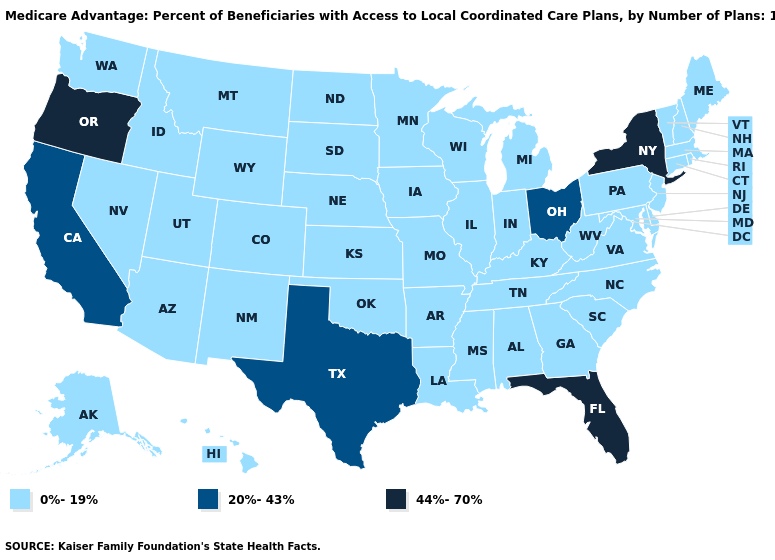Name the states that have a value in the range 0%-19%?
Quick response, please. Alaska, Alabama, Arkansas, Arizona, Colorado, Connecticut, Delaware, Georgia, Hawaii, Iowa, Idaho, Illinois, Indiana, Kansas, Kentucky, Louisiana, Massachusetts, Maryland, Maine, Michigan, Minnesota, Missouri, Mississippi, Montana, North Carolina, North Dakota, Nebraska, New Hampshire, New Jersey, New Mexico, Nevada, Oklahoma, Pennsylvania, Rhode Island, South Carolina, South Dakota, Tennessee, Utah, Virginia, Vermont, Washington, Wisconsin, West Virginia, Wyoming. Does Texas have the lowest value in the South?
Be succinct. No. What is the value of Utah?
Write a very short answer. 0%-19%. Name the states that have a value in the range 44%-70%?
Concise answer only. Florida, New York, Oregon. Which states have the lowest value in the USA?
Keep it brief. Alaska, Alabama, Arkansas, Arizona, Colorado, Connecticut, Delaware, Georgia, Hawaii, Iowa, Idaho, Illinois, Indiana, Kansas, Kentucky, Louisiana, Massachusetts, Maryland, Maine, Michigan, Minnesota, Missouri, Mississippi, Montana, North Carolina, North Dakota, Nebraska, New Hampshire, New Jersey, New Mexico, Nevada, Oklahoma, Pennsylvania, Rhode Island, South Carolina, South Dakota, Tennessee, Utah, Virginia, Vermont, Washington, Wisconsin, West Virginia, Wyoming. What is the highest value in the USA?
Concise answer only. 44%-70%. Name the states that have a value in the range 0%-19%?
Keep it brief. Alaska, Alabama, Arkansas, Arizona, Colorado, Connecticut, Delaware, Georgia, Hawaii, Iowa, Idaho, Illinois, Indiana, Kansas, Kentucky, Louisiana, Massachusetts, Maryland, Maine, Michigan, Minnesota, Missouri, Mississippi, Montana, North Carolina, North Dakota, Nebraska, New Hampshire, New Jersey, New Mexico, Nevada, Oklahoma, Pennsylvania, Rhode Island, South Carolina, South Dakota, Tennessee, Utah, Virginia, Vermont, Washington, Wisconsin, West Virginia, Wyoming. Does the map have missing data?
Give a very brief answer. No. Does Washington have the same value as Oregon?
Concise answer only. No. Does Oregon have the highest value in the USA?
Be succinct. Yes. Does New York have the lowest value in the Northeast?
Answer briefly. No. Does the first symbol in the legend represent the smallest category?
Short answer required. Yes. What is the value of Tennessee?
Be succinct. 0%-19%. Is the legend a continuous bar?
Quick response, please. No. Does Florida have the lowest value in the USA?
Answer briefly. No. 